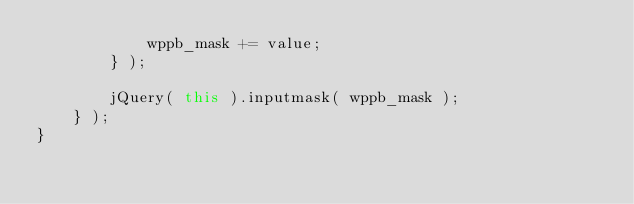Convert code to text. <code><loc_0><loc_0><loc_500><loc_500><_JavaScript_>            wppb_mask += value;
        } );

        jQuery( this ).inputmask( wppb_mask );
    } );
}</code> 